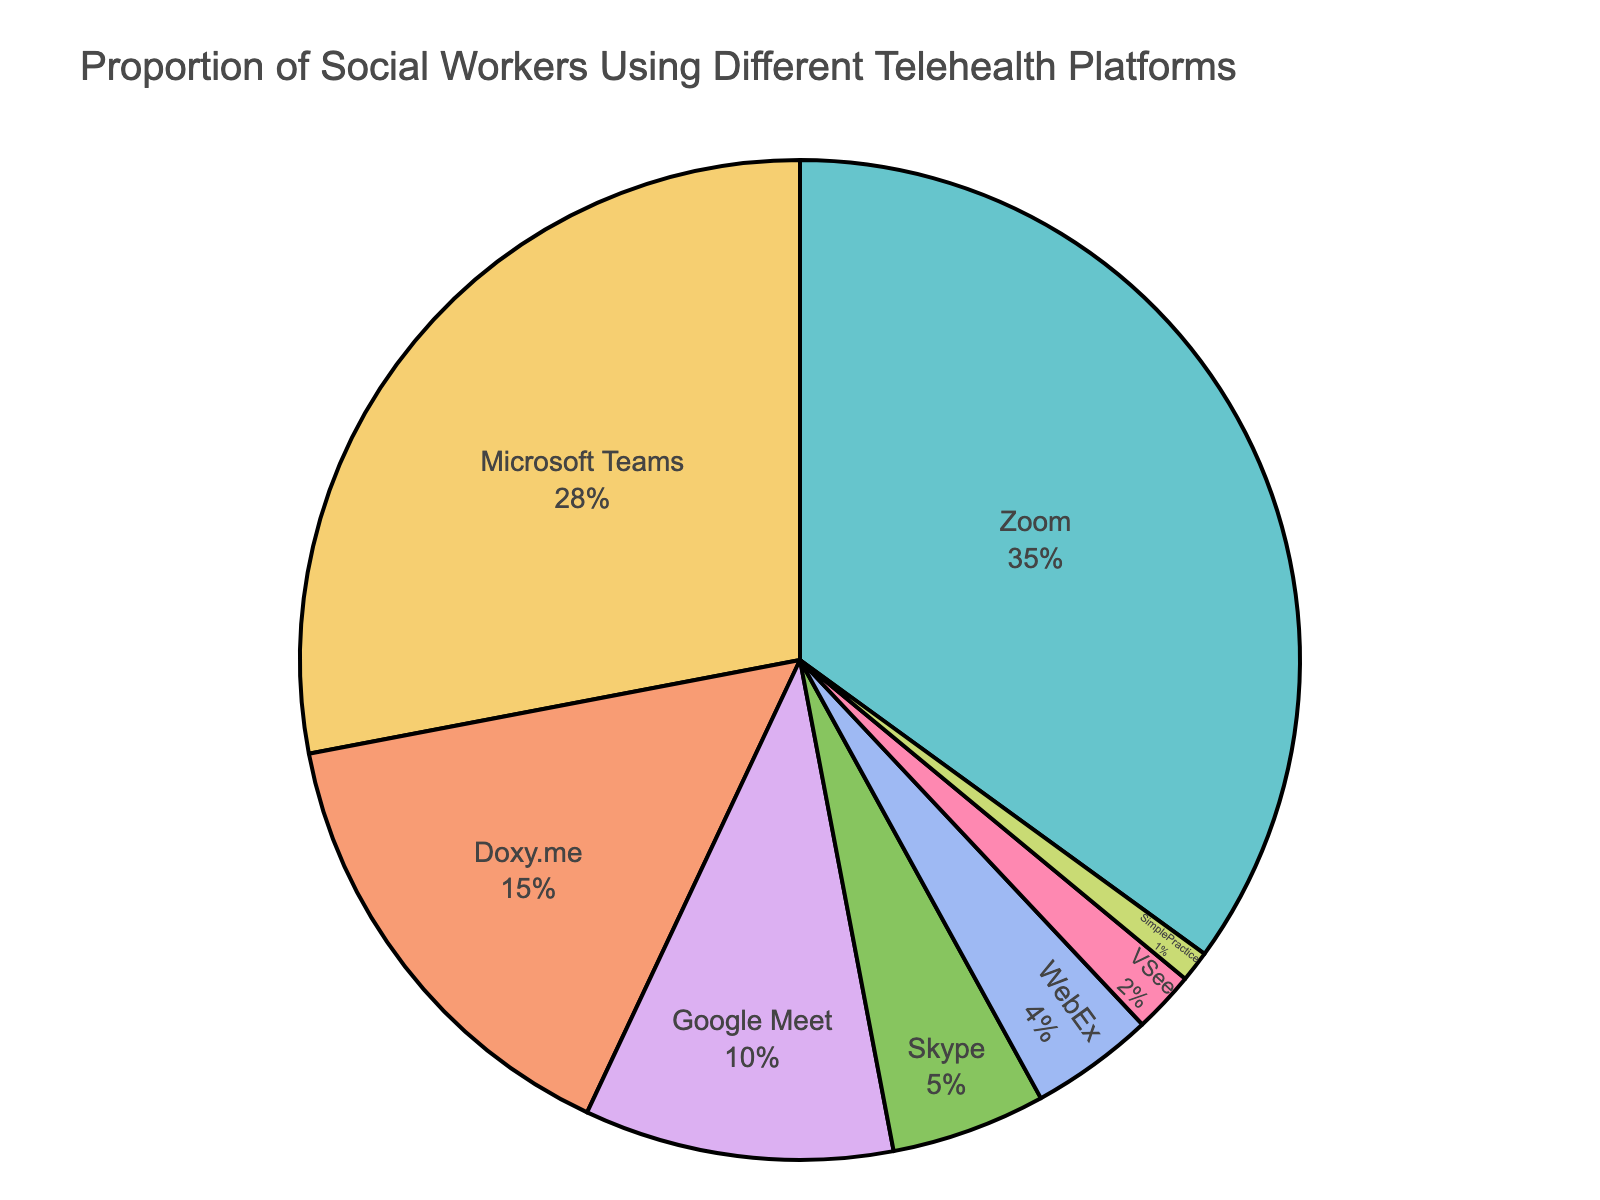What proportion of social workers use Zoom for telehealth? The slice representing Zoom in the pie chart takes up 35% of the circle.
Answer: 35% Which platform is the least used among social workers? By observing the pie chart, the smallest slice corresponds to the platform SimplePractice.
Answer: SimplePractice How does the usage of Microsoft Teams compare to Doxy.me? Microsoft Teams at 28% is almost twice as popular as Doxy.me at 15%.
Answer: Almost twice What is the combined usage percentage of Google Meet and Skype? Google Meet accounts for 10% and Skype accounts for 5%. Adding these together gives 10% + 5% = 15%.
Answer: 15% Is the percentage of social workers using WebEx greater than VSee? The slice for WebEx shows 4%, which is indeed greater than VSee’s 2%.
Answer: Yes Which platform has a higher usage: Doxy.me or Google Meet? Doxy.me is at 15%, while Google Meet is at 10%. 15% is greater than 10%.
Answer: Doxy.me What is the combined proportion of social workers utilizing Zoom, Microsoft Teams, and Doxy.me? Zoom is 35%, Microsoft Teams is 28%, and Doxy.me is 15%. Summing these percentages: 35% + 28% + 15% = 78%.
Answer: 78% How does the usage of Google Meet compare to WebEx? Google Meet’s usage is 10%, which is more than twice the usage of WebEx at 4%.
Answer: More than twice List all the platforms used by less than 5% of social workers. According to the chart, these platforms are Skype (5%), WebEx (4%), VSee (2%), and SimplePractice (1%).
Answer: Skype, WebEx, VSee, SimplePractice Is the proportion of social workers using Microsoft Teams closer to Zoom or Doxy.me? Microsoft Teams is 28%, Zoom is 35%, and Doxy.me is 15%. The difference between Microsoft Teams and Zoom is 7% (35% - 28%), while the difference to Doxy.me is 13% (28% - 15%). 7% is smaller than 13%, indicating Microsoft Teams is closer to Zoom.
Answer: Zoom 